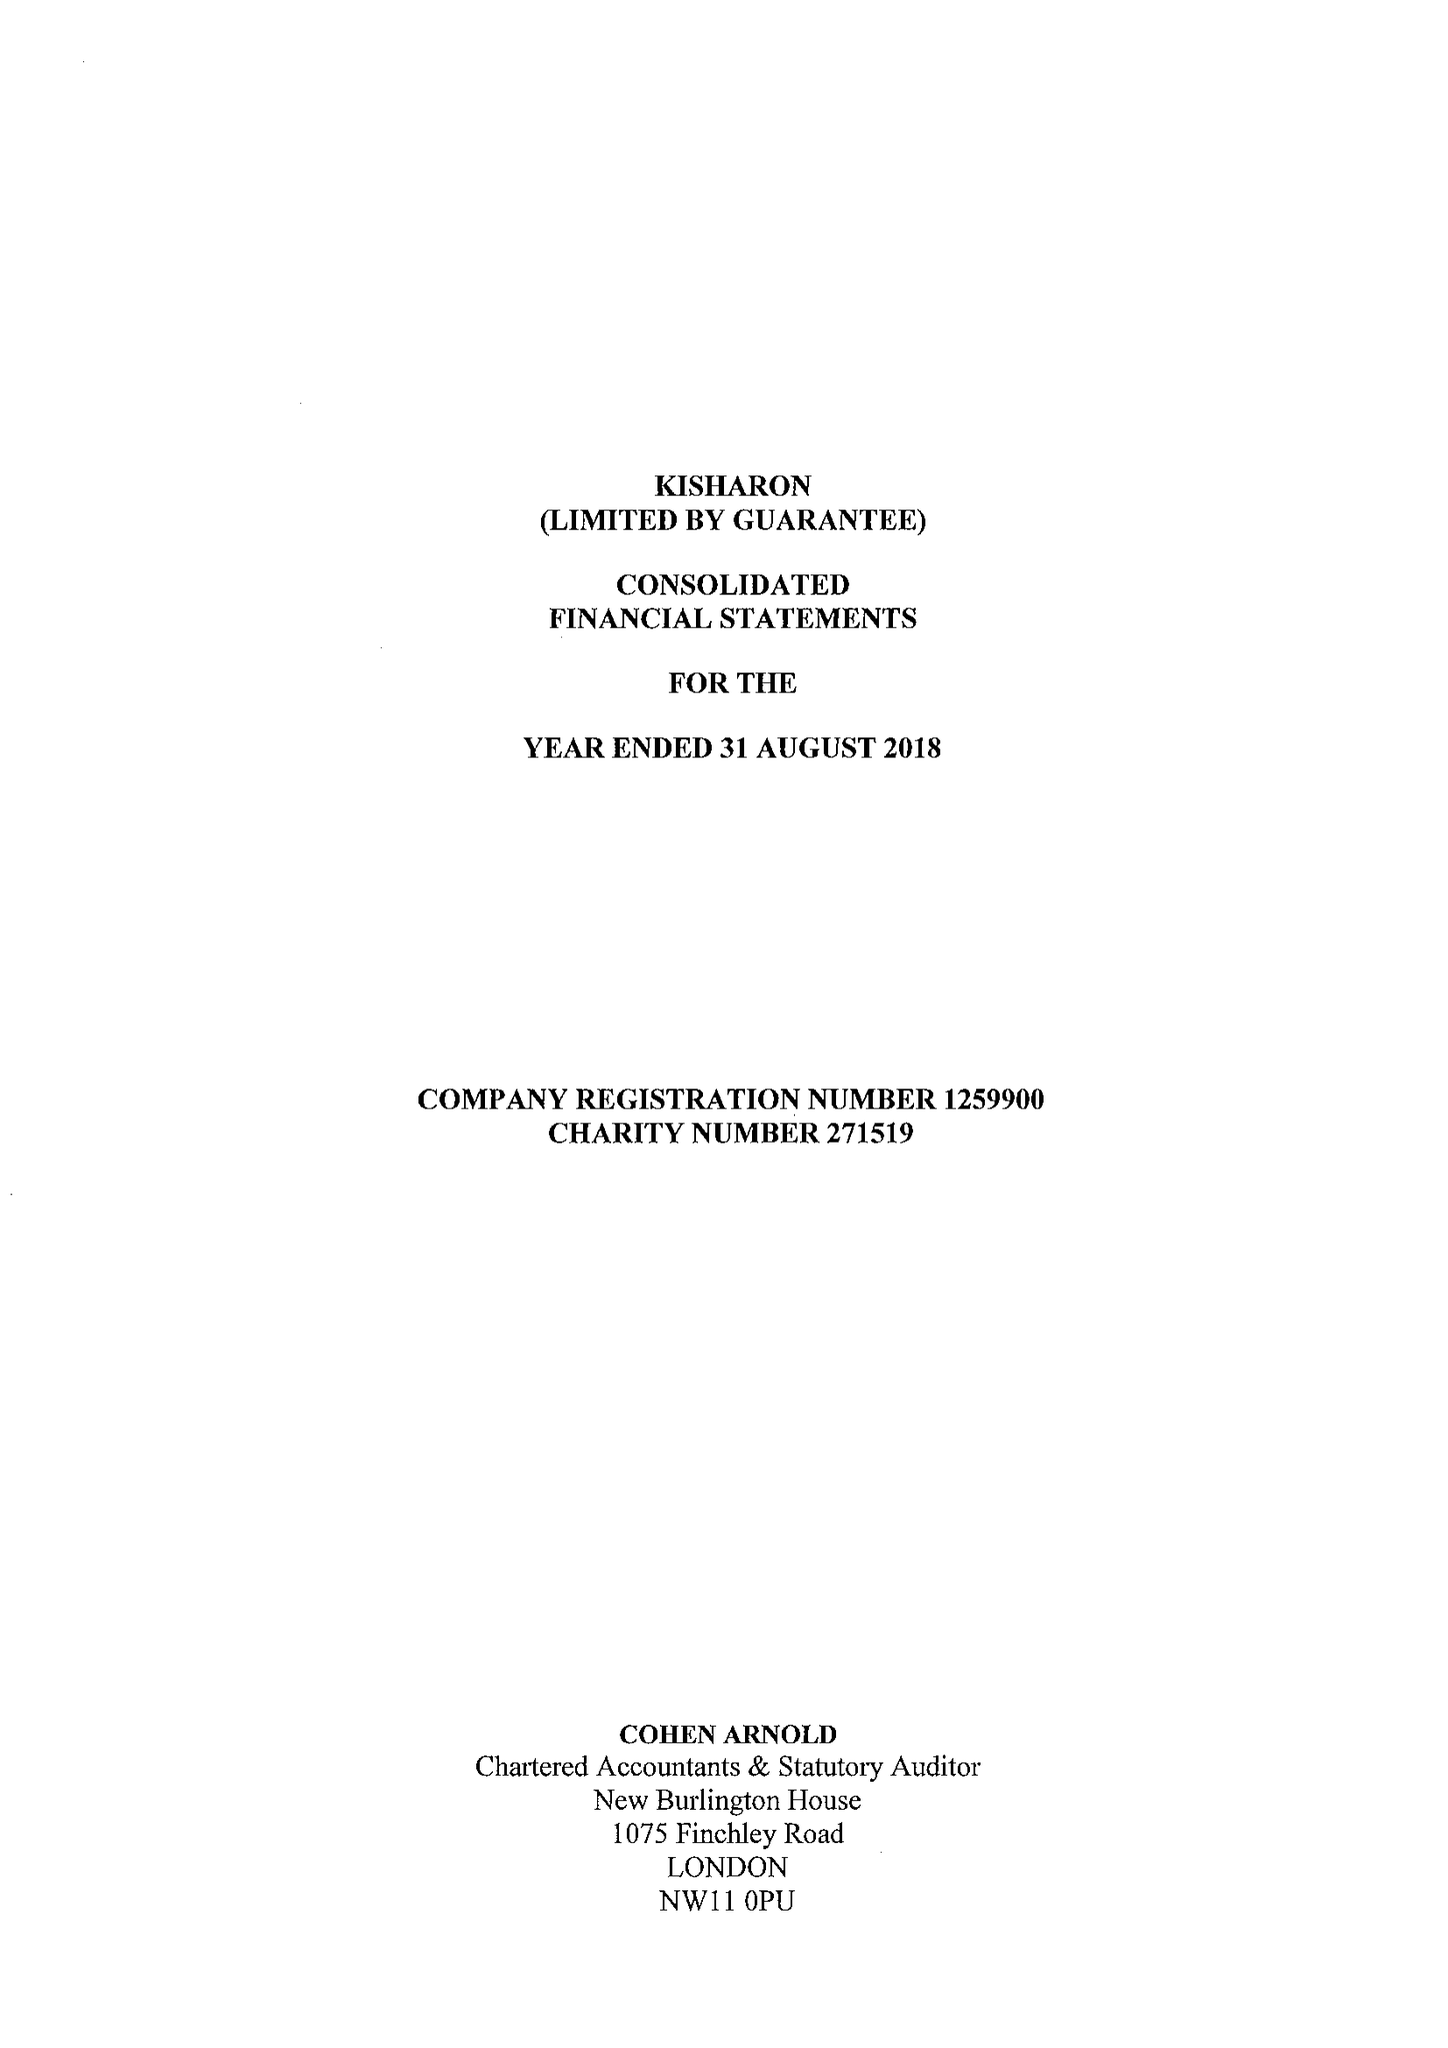What is the value for the address__post_town?
Answer the question using a single word or phrase. LONDON 